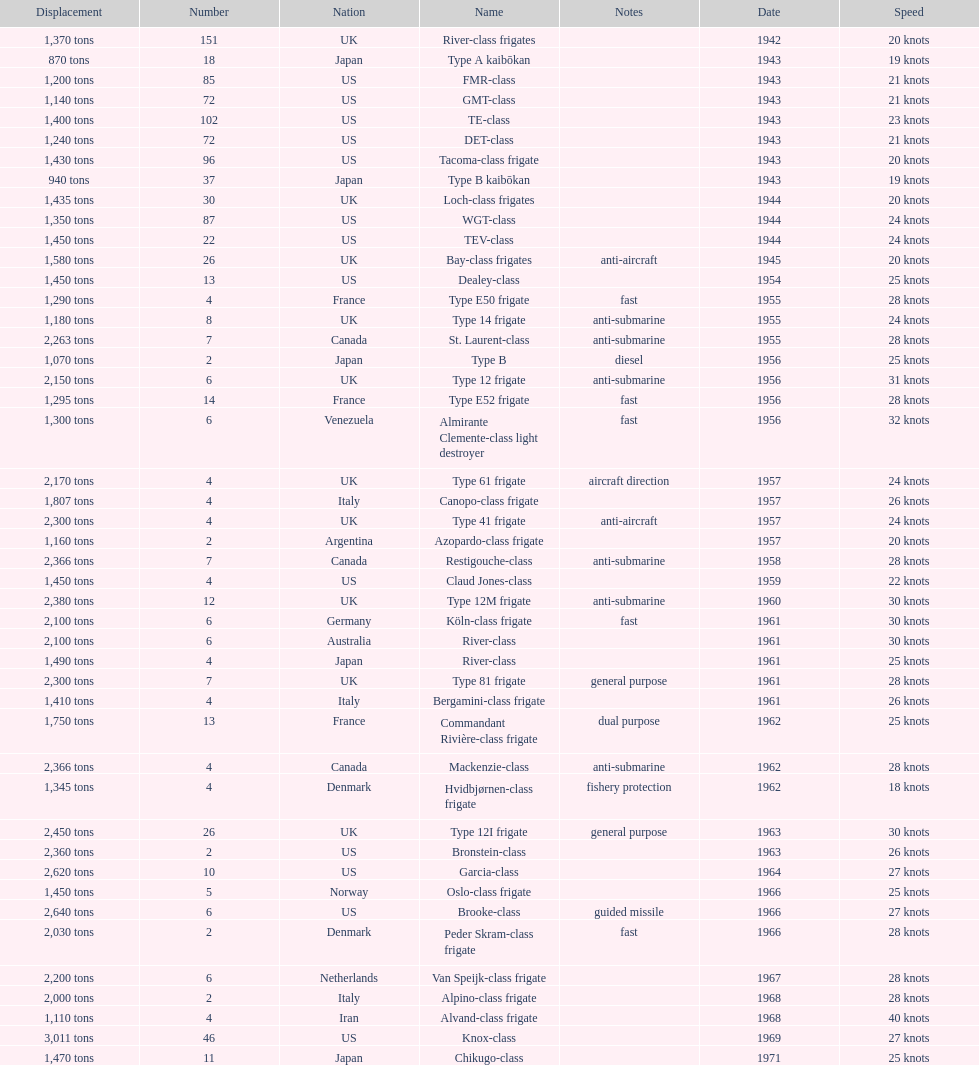In 1968 italy used alpino-class frigate. what was its top speed? 28 knots. 